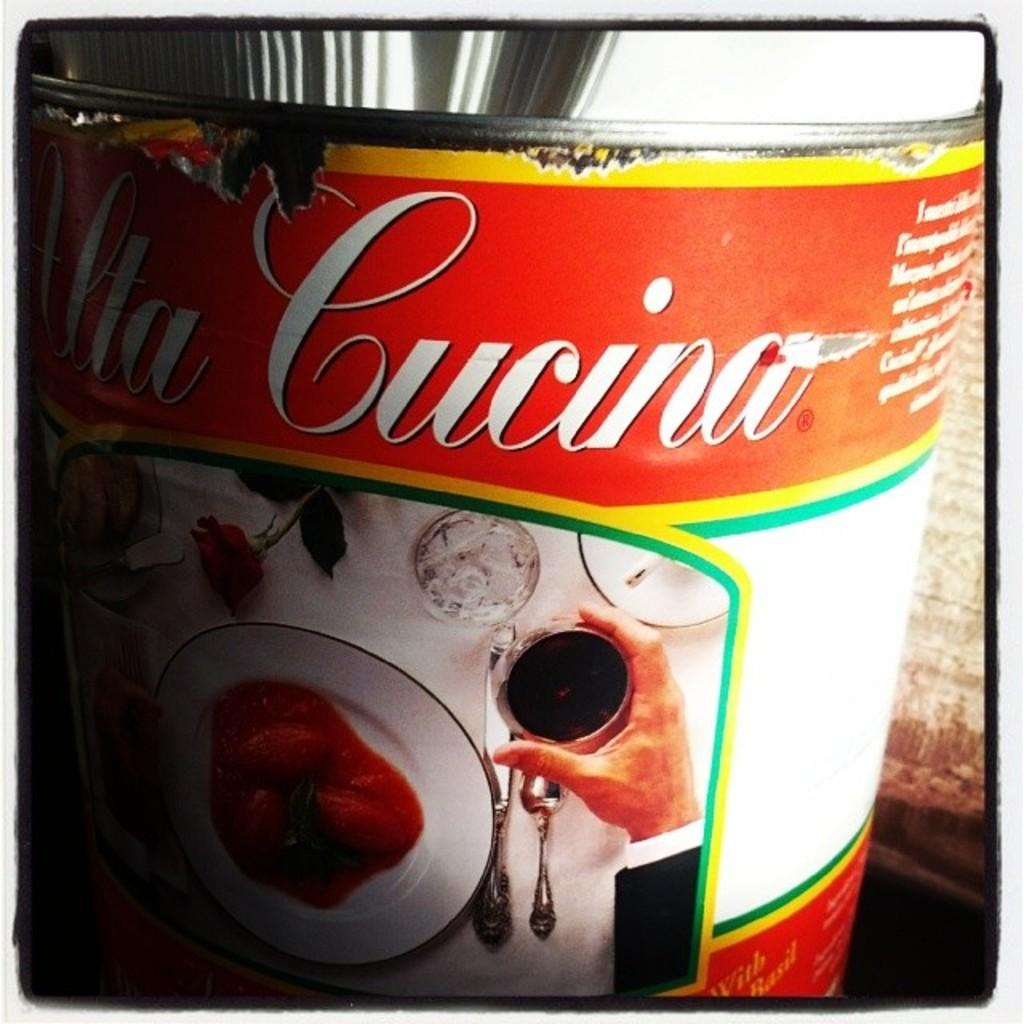Provide a one-sentence caption for the provided image. a cucino can that has white writing on it. 